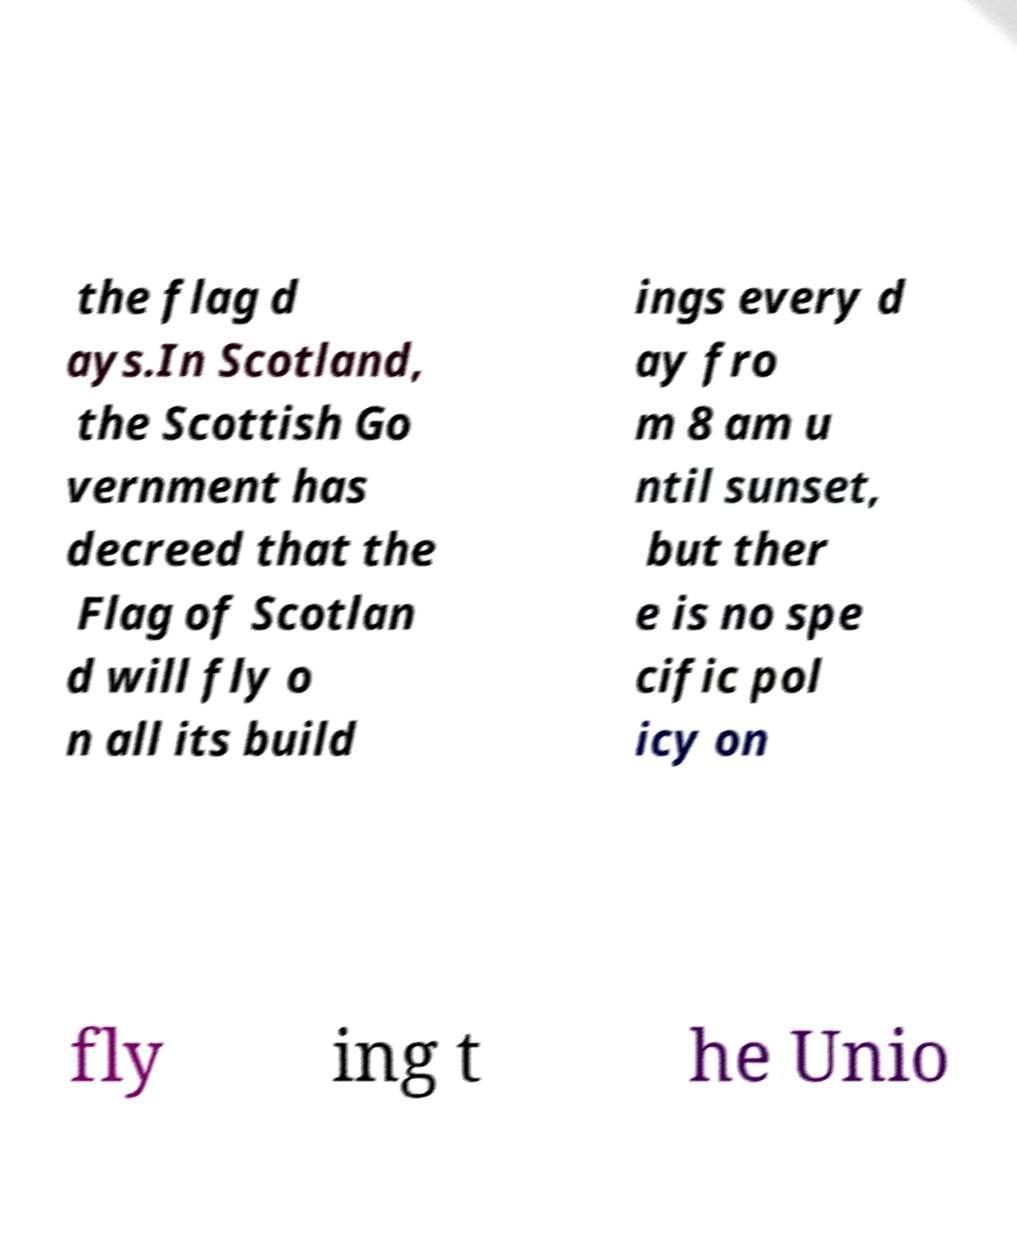Can you accurately transcribe the text from the provided image for me? the flag d ays.In Scotland, the Scottish Go vernment has decreed that the Flag of Scotlan d will fly o n all its build ings every d ay fro m 8 am u ntil sunset, but ther e is no spe cific pol icy on fly ing t he Unio 